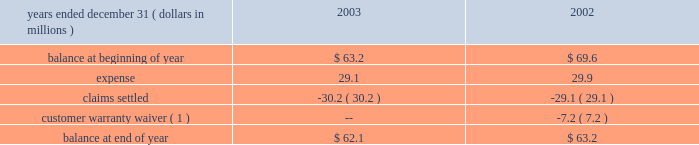Contracts and customer purchase orders are generally used to determine the existence of an arrangement .
Shipping documents are used to verify delivery .
The company assesses whether the selling price is fixed or determinable based upon the payment terms associated with the transaction and whether the sales price is subject to refund or adjustment .
The company assesses collectibility based primarily on the creditworthiness of the customer as determined by credit checks and analysis , as well as the customer 2019s payment history .
Accruals for customer returns for defective product are based on historical experience with similar types of sales .
Accruals for rebates and incentives are based on pricing agreements and are generally tied to sales volume .
Changes in such accruals may be required if future returns differ from historical experience or if actual sales volume differ from estimated sales volume .
Rebates and incentives are recognized as a reduction of sales .
Compensated absences .
In the fourth quarter of 2001 , the company changed its vacation policy for certain employees so that vacation pay is earned ratably throughout the year and must be used by year-end .
The accrual for compensated absences was reduced by $ 1.6 million in 2001 to eliminate vacation pay no longer required to be accrued under the current policy .
Advertising .
Advertising costs are charged to operations as incurred and amounted to $ 18.4 , $ 16.2 and $ 8.8 million during 2003 , 2002 and 2001 respectively .
Research and development .
Research and development costs are charged to operations as incurred and amounted to $ 34.6 , $ 30.4 and $ 27.6 million during 2003 , 2002 and 2001 , respectively .
Product warranty .
The company 2019s products carry warranties that generally range from one to six years and are based on terms that are generally accepted in the market place .
The company records a liability for the expected cost of warranty-related claims at the time of sale .
The allocation of our warranty liability between current and long-term is based on expected warranty claims to be paid in the next year as determined by historical product failure rates .
Organization and significant accounting policies ( continued ) the table presents the company 2019s product warranty liability activity in 2003 and 2002 : note to table : environmental costs .
The company accrues for losses associated with environmental obligations when such losses are probable and reasonably estimable .
Costs of estimated future expenditures are not discounted to their present value .
Recoveries of environmental costs from other parties are recorded as assets when their receipt is considered probable .
The accruals are adjusted as facts and circumstances change .
Stock based compensation .
The company has one stock-based employee compensation plan ( see note 11 ) .
Sfas no .
123 , 201caccounting for stock-based compensation , 201d encourages , but does not require companies to record compensation cost for stock-based employee compensation plans at fair value .
The company has chosen to continue applying accounting principles board opinion no .
25 , 201caccounting for stock issued to employees , 201d and related interpretations , in accounting for its stock option plans .
Accordingly , because the number of shares is fixed and the exercise price of the stock options equals the market price of the underlying stock on the date of grant , no compensation expense has been recognized .
Had compensation cost been determined based upon the fair value at the grant date for awards under the plans based on the provisions of sfas no .
123 , the company 2019s pro forma earnings and earnings per share would have been as follows: .
( 1 ) in exchange for other concessions , the customer has agreed to accept responsibility for units they have purchased from the company which become defective .
The amount of the warranty reserve applicable to the estimated number of units previously sold to this customer that may become defective has been reclassified from the product warranty liability to a deferred revenue account. .
What was the percentage change in research and development costs between 2002 and 2003? 
Computations: ((34.6 - 30.4) / 30.4)
Answer: 0.13816. 